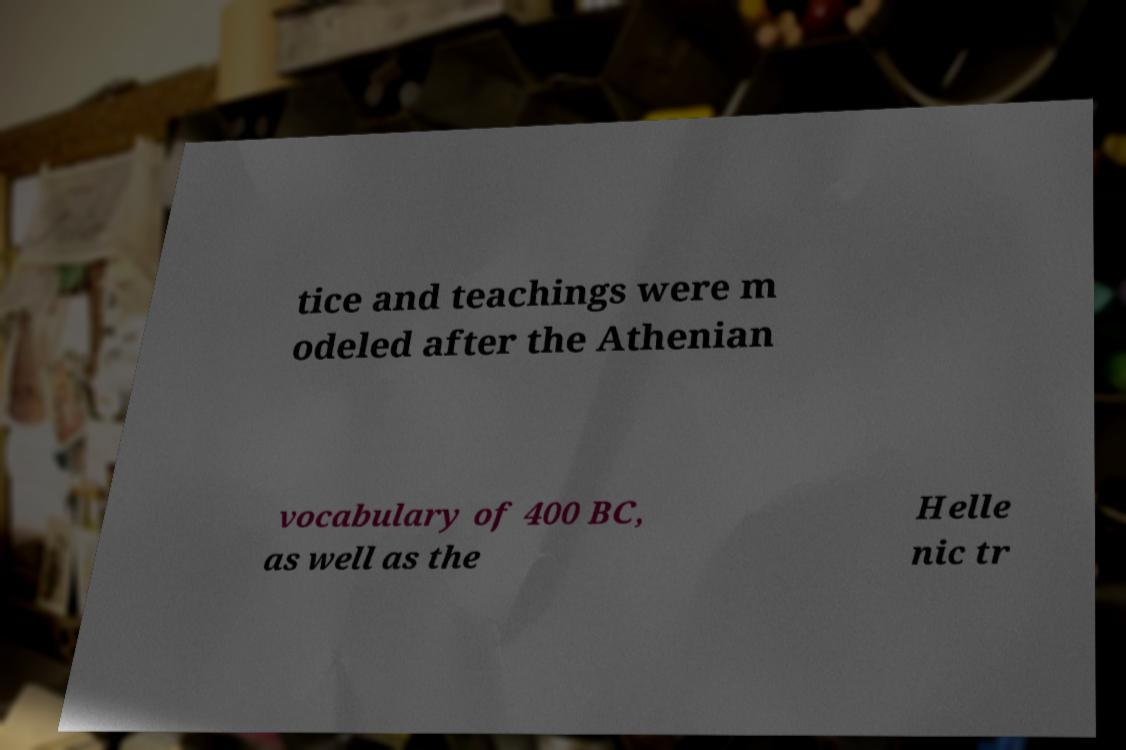I need the written content from this picture converted into text. Can you do that? tice and teachings were m odeled after the Athenian vocabulary of 400 BC, as well as the Helle nic tr 